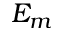Convert formula to latex. <formula><loc_0><loc_0><loc_500><loc_500>E _ { m }</formula> 